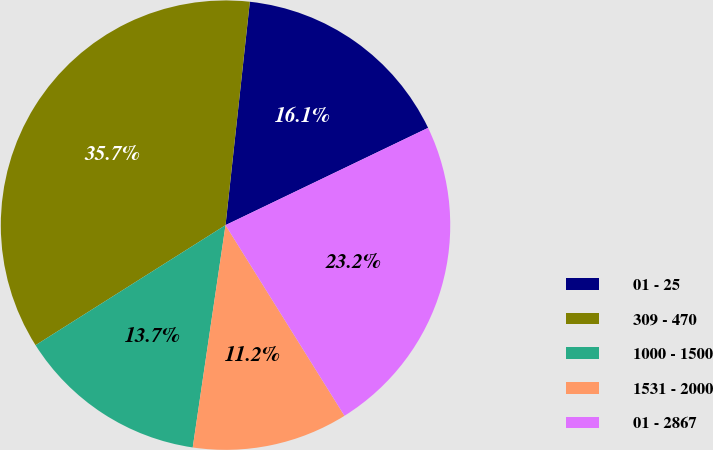Convert chart. <chart><loc_0><loc_0><loc_500><loc_500><pie_chart><fcel>01 - 25<fcel>309 - 470<fcel>1000 - 1500<fcel>1531 - 2000<fcel>01 - 2867<nl><fcel>16.15%<fcel>35.7%<fcel>13.7%<fcel>11.21%<fcel>23.25%<nl></chart> 